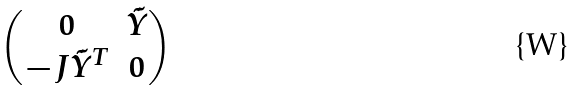Convert formula to latex. <formula><loc_0><loc_0><loc_500><loc_500>\begin{pmatrix} 0 & \tilde { Y } \\ - J \tilde { Y } ^ { T } & 0 \end{pmatrix}</formula> 